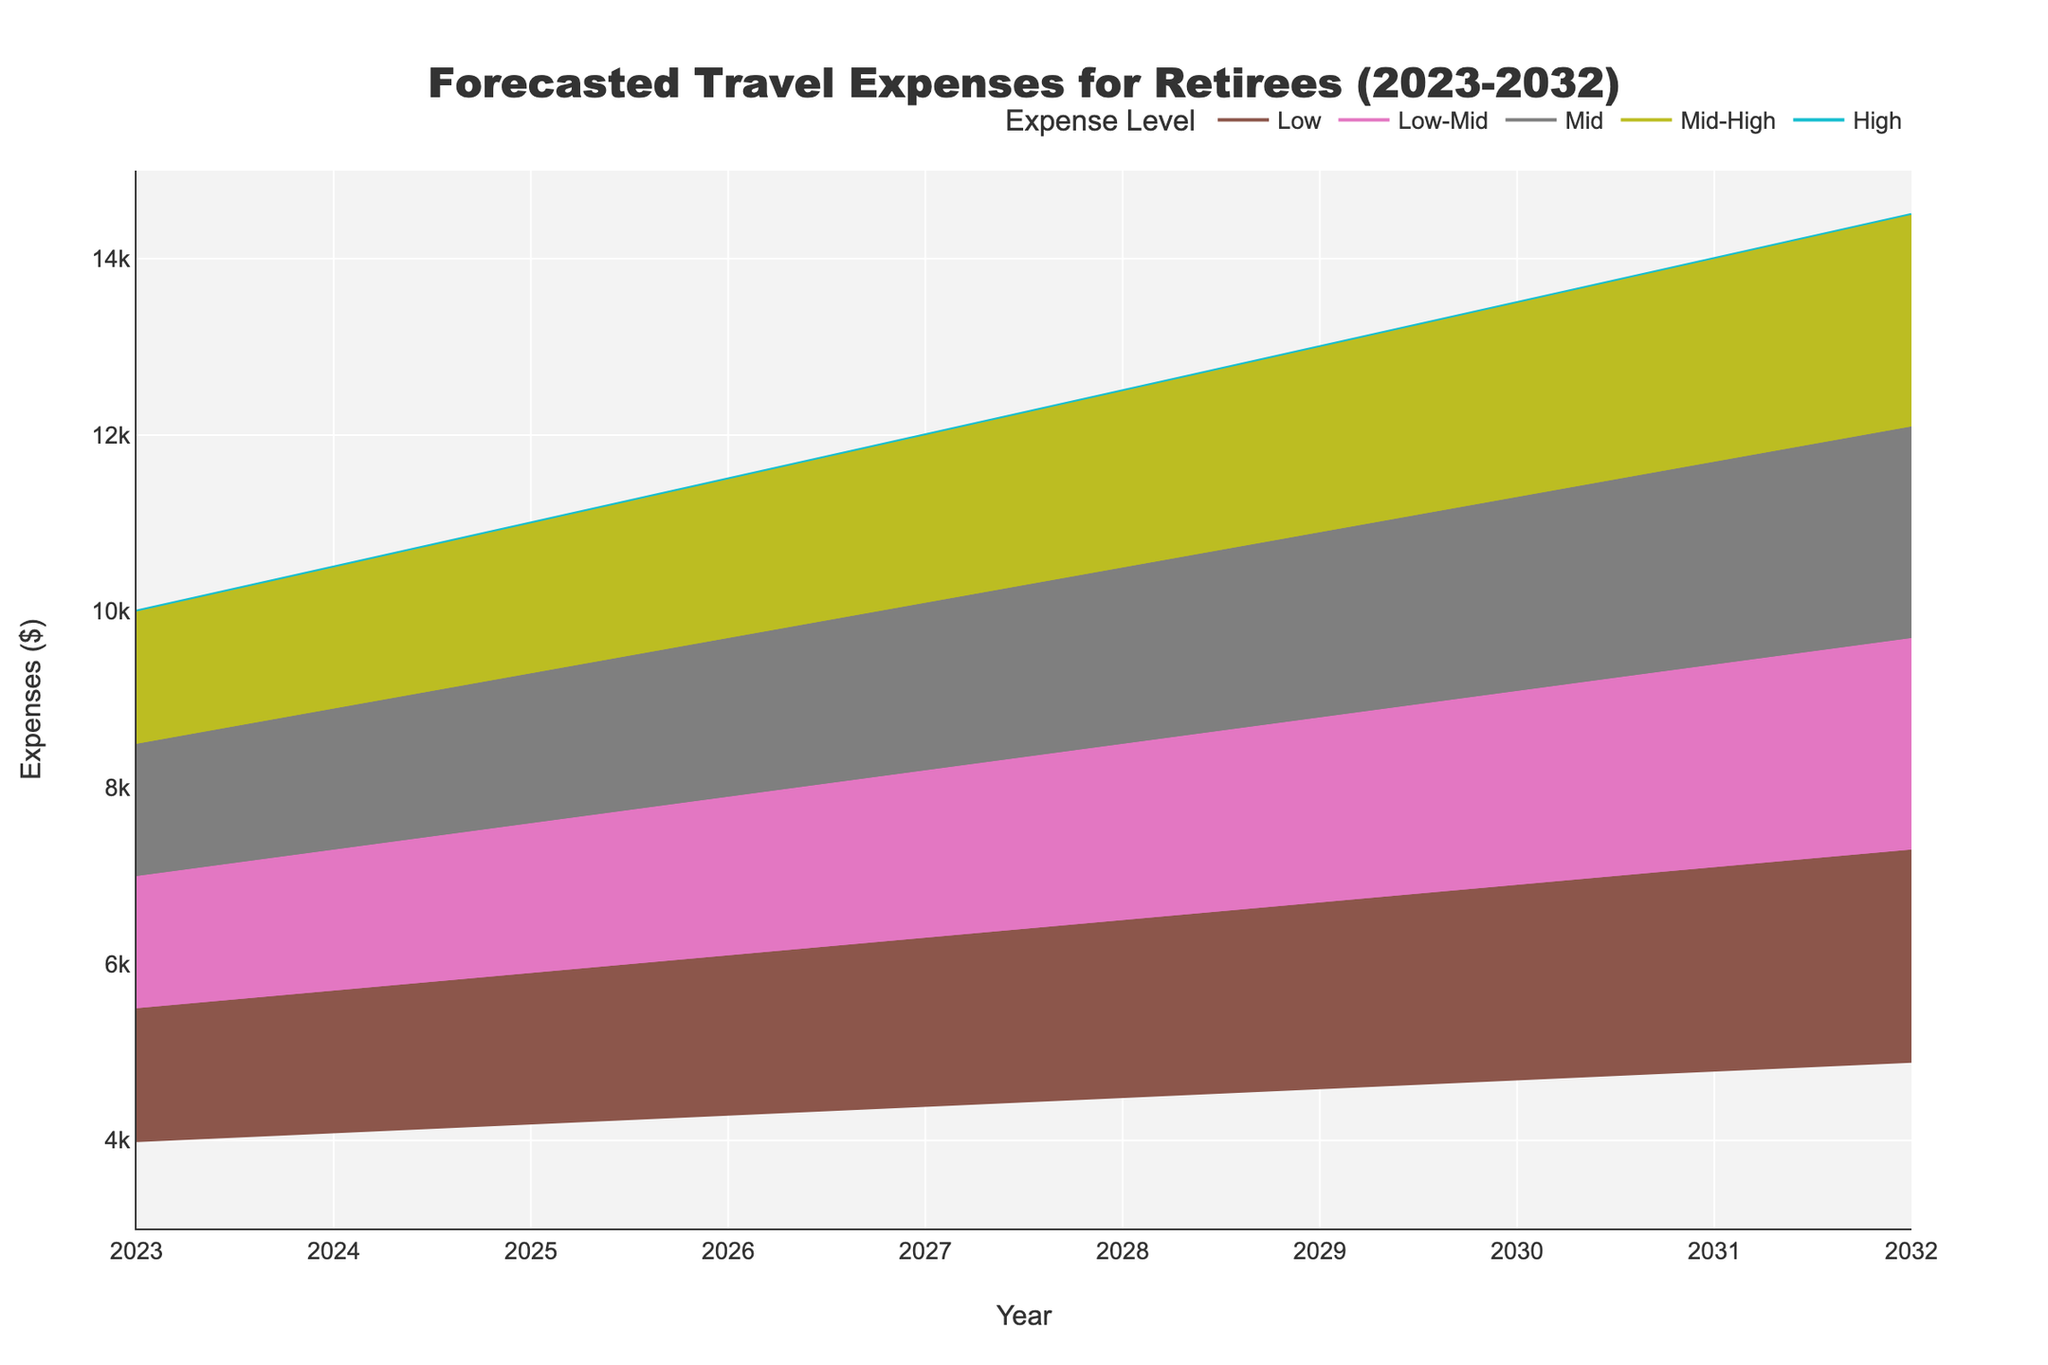what is the title of the figure? The title of the figure is placed at the top center and clearly states the purpose of the visual. It uses a bold, large font to grab attention and provide a quick summary of the chart's content.
Answer: Forecasted Travel Expenses for Retirees (2023-2032) what years are displayed on the x-axis? The x-axis represents the time period covered by the data. In this case, it ranges from the year 2023 to 2032, each year incrementally shown.
Answer: 2023 to 2032 What is the lowest predicted expense for the year 2025? To find this, locate the year 2025 on the x-axis and look at the lowest value plotted on the chart for that year, which corresponds to the "Low" expense level.
Answer: $4200 How much does the highest travel expense increase from 2023 to 2032? First, find the highest values for the years 2023 and 2032. Then subtract the 2023 value from the 2032 value to find the difference. For 2023, the high value is $10000, and for 2032, it is $14500. The increase is 14500 - 10000.
Answer: $4500 What is the range of travel expenses for the year 2028? To determine the range, identify the minimum and maximum expenses for 2028. The min is $4500 (Low) and the max is $12500 (High). Subtract the minimum from the maximum value to find the range, 12500 - 4500.
Answer: $8000 Which expense level shows the smallest variation over the years? Observe each expense level (Low, Low-Mid, Mid, Mid-High, High) and see how much they change year over year. The one with the least year-to-year fluctuation is the Low expense level, as the increase is quite steady and minimal.
Answer: Low Which year has the highest predicted expense level? Scan the chart for the highest peak point among all the years. According to the given data, the year 2032 has the highest values across all expense levels.
Answer: 2032 By how much does the Mid-High expense level increase from 2024 to 2029? Locate the Mid-High values for 2024 and 2029. For 2024, it is $8900, and for 2029, it is $10900. Subtract the smaller value from the larger value, giving 10900 - 8900.
Answer: $2000 What is the average Mid expense over the forecast period? Sum up all the Mid expenses from 2023 to 2032 and then divide that sum by the number of years (10). The Mid expenses are: (7000 + 7300 + 7600 + 7900 + 8200 + 8500 + 8800 + 9100 + 9400 + 9700). The sum is 83500, so the average is 83500 /10.
Answer: $8350 In which year does the Low-Mid expense level exceed $6000? Look along the Low-Mid line until you find the first instance that it crosses the $6000 mark. This happens in the year 2026.
Answer: 2026 